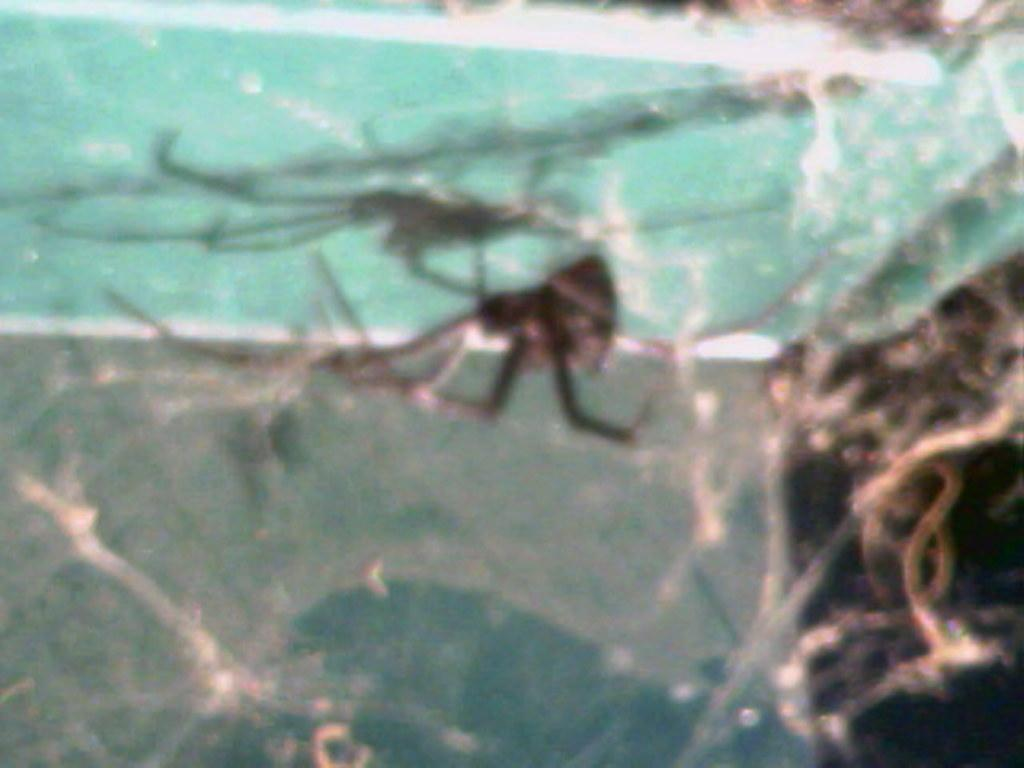What is the quality of the image? The image is blurry. Can you confirm the presence of any specific object in the image? There might be a spider in the image, but its presence cannot be confirmed due to the blurriness of the image. What is the force exerted by the spider in the image? There is no spider present in the image, so it is not possible to determine the force exerted by it. 